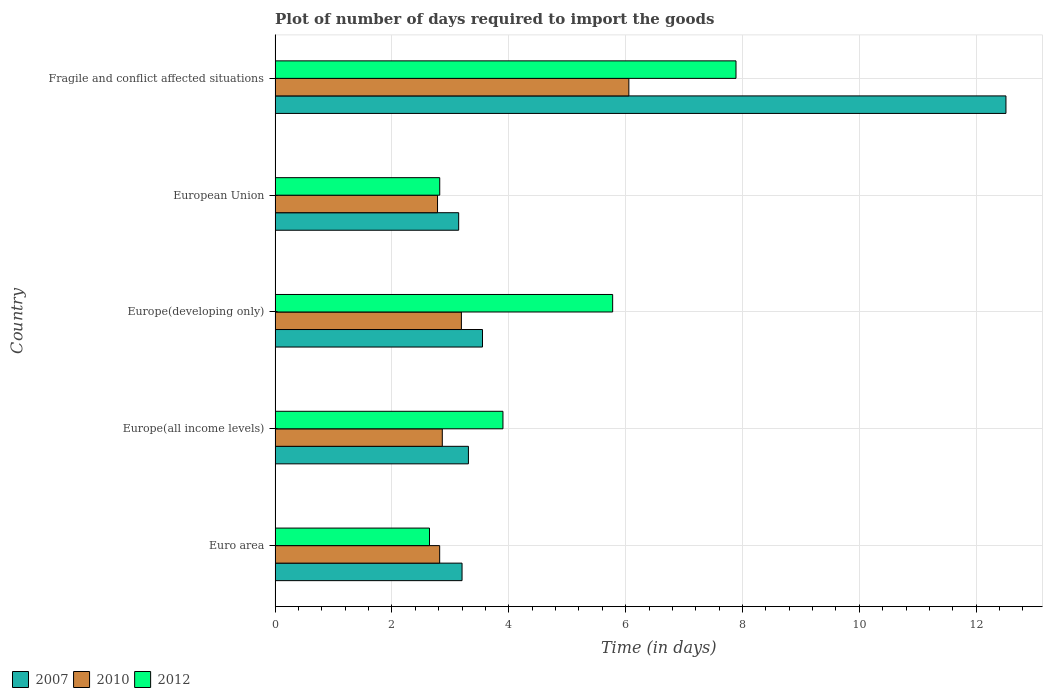How many different coloured bars are there?
Offer a very short reply. 3. Are the number of bars on each tick of the Y-axis equal?
Give a very brief answer. Yes. How many bars are there on the 3rd tick from the top?
Keep it short and to the point. 3. What is the label of the 4th group of bars from the top?
Your answer should be compact. Europe(all income levels). What is the time required to import goods in 2007 in Europe(all income levels)?
Make the answer very short. 3.31. Across all countries, what is the maximum time required to import goods in 2007?
Give a very brief answer. 12.51. Across all countries, what is the minimum time required to import goods in 2010?
Your response must be concise. 2.78. In which country was the time required to import goods in 2010 maximum?
Give a very brief answer. Fragile and conflict affected situations. What is the total time required to import goods in 2012 in the graph?
Make the answer very short. 23.03. What is the difference between the time required to import goods in 2012 in Euro area and that in European Union?
Give a very brief answer. -0.18. What is the difference between the time required to import goods in 2007 in European Union and the time required to import goods in 2012 in Europe(developing only)?
Give a very brief answer. -2.64. What is the average time required to import goods in 2012 per country?
Your response must be concise. 4.61. What is the difference between the time required to import goods in 2012 and time required to import goods in 2007 in Fragile and conflict affected situations?
Keep it short and to the point. -4.62. What is the ratio of the time required to import goods in 2012 in Euro area to that in Europe(all income levels)?
Make the answer very short. 0.68. Is the time required to import goods in 2012 in Europe(developing only) less than that in European Union?
Offer a terse response. No. Is the difference between the time required to import goods in 2012 in Euro area and Europe(all income levels) greater than the difference between the time required to import goods in 2007 in Euro area and Europe(all income levels)?
Give a very brief answer. No. What is the difference between the highest and the second highest time required to import goods in 2012?
Make the answer very short. 2.11. What is the difference between the highest and the lowest time required to import goods in 2012?
Ensure brevity in your answer.  5.25. In how many countries, is the time required to import goods in 2007 greater than the average time required to import goods in 2007 taken over all countries?
Your response must be concise. 1. What does the 2nd bar from the top in Europe(developing only) represents?
Make the answer very short. 2010. What does the 1st bar from the bottom in Europe(developing only) represents?
Keep it short and to the point. 2007. How many bars are there?
Your answer should be compact. 15. Are all the bars in the graph horizontal?
Ensure brevity in your answer.  Yes. Are the values on the major ticks of X-axis written in scientific E-notation?
Provide a succinct answer. No. Does the graph contain any zero values?
Keep it short and to the point. No. Does the graph contain grids?
Offer a very short reply. Yes. Where does the legend appear in the graph?
Provide a short and direct response. Bottom left. How many legend labels are there?
Give a very brief answer. 3. What is the title of the graph?
Make the answer very short. Plot of number of days required to import the goods. Does "1972" appear as one of the legend labels in the graph?
Provide a succinct answer. No. What is the label or title of the X-axis?
Your response must be concise. Time (in days). What is the label or title of the Y-axis?
Your response must be concise. Country. What is the Time (in days) of 2010 in Euro area?
Ensure brevity in your answer.  2.82. What is the Time (in days) in 2012 in Euro area?
Make the answer very short. 2.64. What is the Time (in days) in 2007 in Europe(all income levels)?
Ensure brevity in your answer.  3.31. What is the Time (in days) of 2010 in Europe(all income levels)?
Offer a very short reply. 2.86. What is the Time (in days) of 2007 in Europe(developing only)?
Your answer should be compact. 3.55. What is the Time (in days) in 2010 in Europe(developing only)?
Your response must be concise. 3.19. What is the Time (in days) of 2012 in Europe(developing only)?
Make the answer very short. 5.78. What is the Time (in days) of 2007 in European Union?
Provide a short and direct response. 3.14. What is the Time (in days) in 2010 in European Union?
Your answer should be very brief. 2.78. What is the Time (in days) of 2012 in European Union?
Provide a short and direct response. 2.82. What is the Time (in days) in 2007 in Fragile and conflict affected situations?
Make the answer very short. 12.51. What is the Time (in days) in 2010 in Fragile and conflict affected situations?
Make the answer very short. 6.05. What is the Time (in days) of 2012 in Fragile and conflict affected situations?
Provide a succinct answer. 7.89. Across all countries, what is the maximum Time (in days) of 2007?
Provide a succinct answer. 12.51. Across all countries, what is the maximum Time (in days) in 2010?
Offer a very short reply. 6.05. Across all countries, what is the maximum Time (in days) of 2012?
Give a very brief answer. 7.89. Across all countries, what is the minimum Time (in days) in 2007?
Keep it short and to the point. 3.14. Across all countries, what is the minimum Time (in days) in 2010?
Provide a succinct answer. 2.78. Across all countries, what is the minimum Time (in days) of 2012?
Give a very brief answer. 2.64. What is the total Time (in days) of 2007 in the graph?
Give a very brief answer. 25.71. What is the total Time (in days) of 2010 in the graph?
Offer a terse response. 17.7. What is the total Time (in days) in 2012 in the graph?
Provide a short and direct response. 23.03. What is the difference between the Time (in days) of 2007 in Euro area and that in Europe(all income levels)?
Provide a succinct answer. -0.11. What is the difference between the Time (in days) in 2010 in Euro area and that in Europe(all income levels)?
Your answer should be compact. -0.04. What is the difference between the Time (in days) of 2012 in Euro area and that in Europe(all income levels)?
Your answer should be compact. -1.26. What is the difference between the Time (in days) of 2007 in Euro area and that in Europe(developing only)?
Give a very brief answer. -0.35. What is the difference between the Time (in days) of 2010 in Euro area and that in Europe(developing only)?
Provide a short and direct response. -0.37. What is the difference between the Time (in days) of 2012 in Euro area and that in Europe(developing only)?
Keep it short and to the point. -3.13. What is the difference between the Time (in days) in 2007 in Euro area and that in European Union?
Give a very brief answer. 0.06. What is the difference between the Time (in days) of 2010 in Euro area and that in European Union?
Ensure brevity in your answer.  0.04. What is the difference between the Time (in days) of 2012 in Euro area and that in European Union?
Your answer should be compact. -0.18. What is the difference between the Time (in days) in 2007 in Euro area and that in Fragile and conflict affected situations?
Your response must be concise. -9.31. What is the difference between the Time (in days) of 2010 in Euro area and that in Fragile and conflict affected situations?
Ensure brevity in your answer.  -3.24. What is the difference between the Time (in days) in 2012 in Euro area and that in Fragile and conflict affected situations?
Your answer should be very brief. -5.25. What is the difference between the Time (in days) in 2007 in Europe(all income levels) and that in Europe(developing only)?
Give a very brief answer. -0.24. What is the difference between the Time (in days) of 2010 in Europe(all income levels) and that in Europe(developing only)?
Offer a terse response. -0.33. What is the difference between the Time (in days) of 2012 in Europe(all income levels) and that in Europe(developing only)?
Your answer should be very brief. -1.88. What is the difference between the Time (in days) of 2007 in Europe(all income levels) and that in European Union?
Provide a succinct answer. 0.17. What is the difference between the Time (in days) of 2010 in Europe(all income levels) and that in European Union?
Offer a terse response. 0.08. What is the difference between the Time (in days) of 2012 in Europe(all income levels) and that in European Union?
Keep it short and to the point. 1.08. What is the difference between the Time (in days) in 2010 in Europe(all income levels) and that in Fragile and conflict affected situations?
Keep it short and to the point. -3.19. What is the difference between the Time (in days) in 2012 in Europe(all income levels) and that in Fragile and conflict affected situations?
Your answer should be compact. -3.99. What is the difference between the Time (in days) of 2007 in Europe(developing only) and that in European Union?
Provide a succinct answer. 0.41. What is the difference between the Time (in days) in 2010 in Europe(developing only) and that in European Union?
Give a very brief answer. 0.41. What is the difference between the Time (in days) of 2012 in Europe(developing only) and that in European Union?
Provide a short and direct response. 2.96. What is the difference between the Time (in days) of 2007 in Europe(developing only) and that in Fragile and conflict affected situations?
Offer a very short reply. -8.96. What is the difference between the Time (in days) of 2010 in Europe(developing only) and that in Fragile and conflict affected situations?
Your answer should be compact. -2.87. What is the difference between the Time (in days) of 2012 in Europe(developing only) and that in Fragile and conflict affected situations?
Your answer should be very brief. -2.11. What is the difference between the Time (in days) of 2007 in European Union and that in Fragile and conflict affected situations?
Your answer should be very brief. -9.37. What is the difference between the Time (in days) in 2010 in European Union and that in Fragile and conflict affected situations?
Provide a short and direct response. -3.27. What is the difference between the Time (in days) of 2012 in European Union and that in Fragile and conflict affected situations?
Offer a terse response. -5.07. What is the difference between the Time (in days) in 2007 in Euro area and the Time (in days) in 2010 in Europe(all income levels)?
Keep it short and to the point. 0.34. What is the difference between the Time (in days) of 2007 in Euro area and the Time (in days) of 2012 in Europe(all income levels)?
Offer a terse response. -0.7. What is the difference between the Time (in days) in 2010 in Euro area and the Time (in days) in 2012 in Europe(all income levels)?
Make the answer very short. -1.08. What is the difference between the Time (in days) of 2007 in Euro area and the Time (in days) of 2010 in Europe(developing only)?
Provide a short and direct response. 0.01. What is the difference between the Time (in days) in 2007 in Euro area and the Time (in days) in 2012 in Europe(developing only)?
Provide a succinct answer. -2.58. What is the difference between the Time (in days) of 2010 in Euro area and the Time (in days) of 2012 in Europe(developing only)?
Your response must be concise. -2.96. What is the difference between the Time (in days) in 2007 in Euro area and the Time (in days) in 2010 in European Union?
Provide a short and direct response. 0.42. What is the difference between the Time (in days) of 2007 in Euro area and the Time (in days) of 2012 in European Union?
Offer a very short reply. 0.38. What is the difference between the Time (in days) in 2010 in Euro area and the Time (in days) in 2012 in European Union?
Make the answer very short. -0. What is the difference between the Time (in days) in 2007 in Euro area and the Time (in days) in 2010 in Fragile and conflict affected situations?
Your answer should be compact. -2.85. What is the difference between the Time (in days) of 2007 in Euro area and the Time (in days) of 2012 in Fragile and conflict affected situations?
Your answer should be very brief. -4.69. What is the difference between the Time (in days) in 2010 in Euro area and the Time (in days) in 2012 in Fragile and conflict affected situations?
Keep it short and to the point. -5.07. What is the difference between the Time (in days) of 2007 in Europe(all income levels) and the Time (in days) of 2010 in Europe(developing only)?
Provide a succinct answer. 0.12. What is the difference between the Time (in days) in 2007 in Europe(all income levels) and the Time (in days) in 2012 in Europe(developing only)?
Give a very brief answer. -2.47. What is the difference between the Time (in days) of 2010 in Europe(all income levels) and the Time (in days) of 2012 in Europe(developing only)?
Your answer should be compact. -2.92. What is the difference between the Time (in days) of 2007 in Europe(all income levels) and the Time (in days) of 2010 in European Union?
Your response must be concise. 0.53. What is the difference between the Time (in days) of 2007 in Europe(all income levels) and the Time (in days) of 2012 in European Union?
Keep it short and to the point. 0.49. What is the difference between the Time (in days) in 2010 in Europe(all income levels) and the Time (in days) in 2012 in European Union?
Your response must be concise. 0.04. What is the difference between the Time (in days) in 2007 in Europe(all income levels) and the Time (in days) in 2010 in Fragile and conflict affected situations?
Ensure brevity in your answer.  -2.75. What is the difference between the Time (in days) of 2007 in Europe(all income levels) and the Time (in days) of 2012 in Fragile and conflict affected situations?
Ensure brevity in your answer.  -4.58. What is the difference between the Time (in days) of 2010 in Europe(all income levels) and the Time (in days) of 2012 in Fragile and conflict affected situations?
Your answer should be very brief. -5.03. What is the difference between the Time (in days) of 2007 in Europe(developing only) and the Time (in days) of 2010 in European Union?
Your answer should be very brief. 0.77. What is the difference between the Time (in days) of 2007 in Europe(developing only) and the Time (in days) of 2012 in European Union?
Offer a very short reply. 0.73. What is the difference between the Time (in days) of 2010 in Europe(developing only) and the Time (in days) of 2012 in European Union?
Provide a short and direct response. 0.37. What is the difference between the Time (in days) of 2007 in Europe(developing only) and the Time (in days) of 2010 in Fragile and conflict affected situations?
Give a very brief answer. -2.5. What is the difference between the Time (in days) of 2007 in Europe(developing only) and the Time (in days) of 2012 in Fragile and conflict affected situations?
Ensure brevity in your answer.  -4.34. What is the difference between the Time (in days) of 2010 in Europe(developing only) and the Time (in days) of 2012 in Fragile and conflict affected situations?
Ensure brevity in your answer.  -4.7. What is the difference between the Time (in days) in 2007 in European Union and the Time (in days) in 2010 in Fragile and conflict affected situations?
Keep it short and to the point. -2.91. What is the difference between the Time (in days) in 2007 in European Union and the Time (in days) in 2012 in Fragile and conflict affected situations?
Provide a short and direct response. -4.75. What is the difference between the Time (in days) of 2010 in European Union and the Time (in days) of 2012 in Fragile and conflict affected situations?
Your answer should be very brief. -5.11. What is the average Time (in days) of 2007 per country?
Offer a terse response. 5.14. What is the average Time (in days) in 2010 per country?
Provide a succinct answer. 3.54. What is the average Time (in days) of 2012 per country?
Offer a very short reply. 4.61. What is the difference between the Time (in days) of 2007 and Time (in days) of 2010 in Euro area?
Keep it short and to the point. 0.38. What is the difference between the Time (in days) in 2007 and Time (in days) in 2012 in Euro area?
Ensure brevity in your answer.  0.56. What is the difference between the Time (in days) of 2010 and Time (in days) of 2012 in Euro area?
Provide a succinct answer. 0.17. What is the difference between the Time (in days) in 2007 and Time (in days) in 2010 in Europe(all income levels)?
Your answer should be very brief. 0.45. What is the difference between the Time (in days) in 2007 and Time (in days) in 2012 in Europe(all income levels)?
Give a very brief answer. -0.59. What is the difference between the Time (in days) of 2010 and Time (in days) of 2012 in Europe(all income levels)?
Offer a very short reply. -1.04. What is the difference between the Time (in days) in 2007 and Time (in days) in 2010 in Europe(developing only)?
Offer a terse response. 0.36. What is the difference between the Time (in days) of 2007 and Time (in days) of 2012 in Europe(developing only)?
Your answer should be very brief. -2.23. What is the difference between the Time (in days) of 2010 and Time (in days) of 2012 in Europe(developing only)?
Provide a succinct answer. -2.59. What is the difference between the Time (in days) of 2007 and Time (in days) of 2010 in European Union?
Provide a succinct answer. 0.36. What is the difference between the Time (in days) in 2007 and Time (in days) in 2012 in European Union?
Your answer should be very brief. 0.32. What is the difference between the Time (in days) in 2010 and Time (in days) in 2012 in European Union?
Ensure brevity in your answer.  -0.04. What is the difference between the Time (in days) of 2007 and Time (in days) of 2010 in Fragile and conflict affected situations?
Offer a very short reply. 6.45. What is the difference between the Time (in days) in 2007 and Time (in days) in 2012 in Fragile and conflict affected situations?
Offer a terse response. 4.62. What is the difference between the Time (in days) in 2010 and Time (in days) in 2012 in Fragile and conflict affected situations?
Provide a short and direct response. -1.83. What is the ratio of the Time (in days) of 2007 in Euro area to that in Europe(all income levels)?
Provide a short and direct response. 0.97. What is the ratio of the Time (in days) in 2010 in Euro area to that in Europe(all income levels)?
Your answer should be very brief. 0.98. What is the ratio of the Time (in days) of 2012 in Euro area to that in Europe(all income levels)?
Give a very brief answer. 0.68. What is the ratio of the Time (in days) in 2007 in Euro area to that in Europe(developing only)?
Make the answer very short. 0.9. What is the ratio of the Time (in days) of 2010 in Euro area to that in Europe(developing only)?
Your response must be concise. 0.88. What is the ratio of the Time (in days) of 2012 in Euro area to that in Europe(developing only)?
Your response must be concise. 0.46. What is the ratio of the Time (in days) of 2007 in Euro area to that in European Union?
Give a very brief answer. 1.02. What is the ratio of the Time (in days) in 2010 in Euro area to that in European Union?
Your answer should be compact. 1.01. What is the ratio of the Time (in days) in 2012 in Euro area to that in European Union?
Provide a short and direct response. 0.94. What is the ratio of the Time (in days) in 2007 in Euro area to that in Fragile and conflict affected situations?
Your answer should be very brief. 0.26. What is the ratio of the Time (in days) in 2010 in Euro area to that in Fragile and conflict affected situations?
Your answer should be very brief. 0.47. What is the ratio of the Time (in days) in 2012 in Euro area to that in Fragile and conflict affected situations?
Keep it short and to the point. 0.34. What is the ratio of the Time (in days) of 2007 in Europe(all income levels) to that in Europe(developing only)?
Ensure brevity in your answer.  0.93. What is the ratio of the Time (in days) in 2010 in Europe(all income levels) to that in Europe(developing only)?
Offer a very short reply. 0.9. What is the ratio of the Time (in days) of 2012 in Europe(all income levels) to that in Europe(developing only)?
Give a very brief answer. 0.68. What is the ratio of the Time (in days) of 2007 in Europe(all income levels) to that in European Union?
Provide a succinct answer. 1.05. What is the ratio of the Time (in days) of 2010 in Europe(all income levels) to that in European Union?
Ensure brevity in your answer.  1.03. What is the ratio of the Time (in days) of 2012 in Europe(all income levels) to that in European Union?
Keep it short and to the point. 1.38. What is the ratio of the Time (in days) in 2007 in Europe(all income levels) to that in Fragile and conflict affected situations?
Offer a very short reply. 0.26. What is the ratio of the Time (in days) of 2010 in Europe(all income levels) to that in Fragile and conflict affected situations?
Make the answer very short. 0.47. What is the ratio of the Time (in days) in 2012 in Europe(all income levels) to that in Fragile and conflict affected situations?
Keep it short and to the point. 0.49. What is the ratio of the Time (in days) of 2007 in Europe(developing only) to that in European Union?
Ensure brevity in your answer.  1.13. What is the ratio of the Time (in days) in 2010 in Europe(developing only) to that in European Union?
Offer a terse response. 1.15. What is the ratio of the Time (in days) in 2012 in Europe(developing only) to that in European Union?
Provide a short and direct response. 2.05. What is the ratio of the Time (in days) in 2007 in Europe(developing only) to that in Fragile and conflict affected situations?
Provide a succinct answer. 0.28. What is the ratio of the Time (in days) in 2010 in Europe(developing only) to that in Fragile and conflict affected situations?
Your answer should be very brief. 0.53. What is the ratio of the Time (in days) of 2012 in Europe(developing only) to that in Fragile and conflict affected situations?
Offer a terse response. 0.73. What is the ratio of the Time (in days) in 2007 in European Union to that in Fragile and conflict affected situations?
Provide a succinct answer. 0.25. What is the ratio of the Time (in days) in 2010 in European Union to that in Fragile and conflict affected situations?
Keep it short and to the point. 0.46. What is the ratio of the Time (in days) of 2012 in European Union to that in Fragile and conflict affected situations?
Offer a terse response. 0.36. What is the difference between the highest and the second highest Time (in days) in 2007?
Provide a short and direct response. 8.96. What is the difference between the highest and the second highest Time (in days) of 2010?
Your answer should be very brief. 2.87. What is the difference between the highest and the second highest Time (in days) of 2012?
Provide a short and direct response. 2.11. What is the difference between the highest and the lowest Time (in days) in 2007?
Provide a short and direct response. 9.37. What is the difference between the highest and the lowest Time (in days) in 2010?
Ensure brevity in your answer.  3.27. What is the difference between the highest and the lowest Time (in days) of 2012?
Make the answer very short. 5.25. 